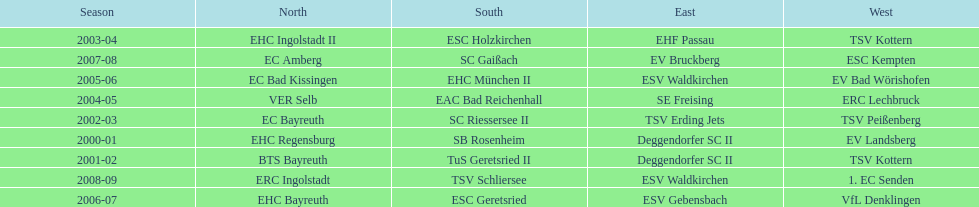The only team to win the north in 2000-01 season? EHC Regensburg. 